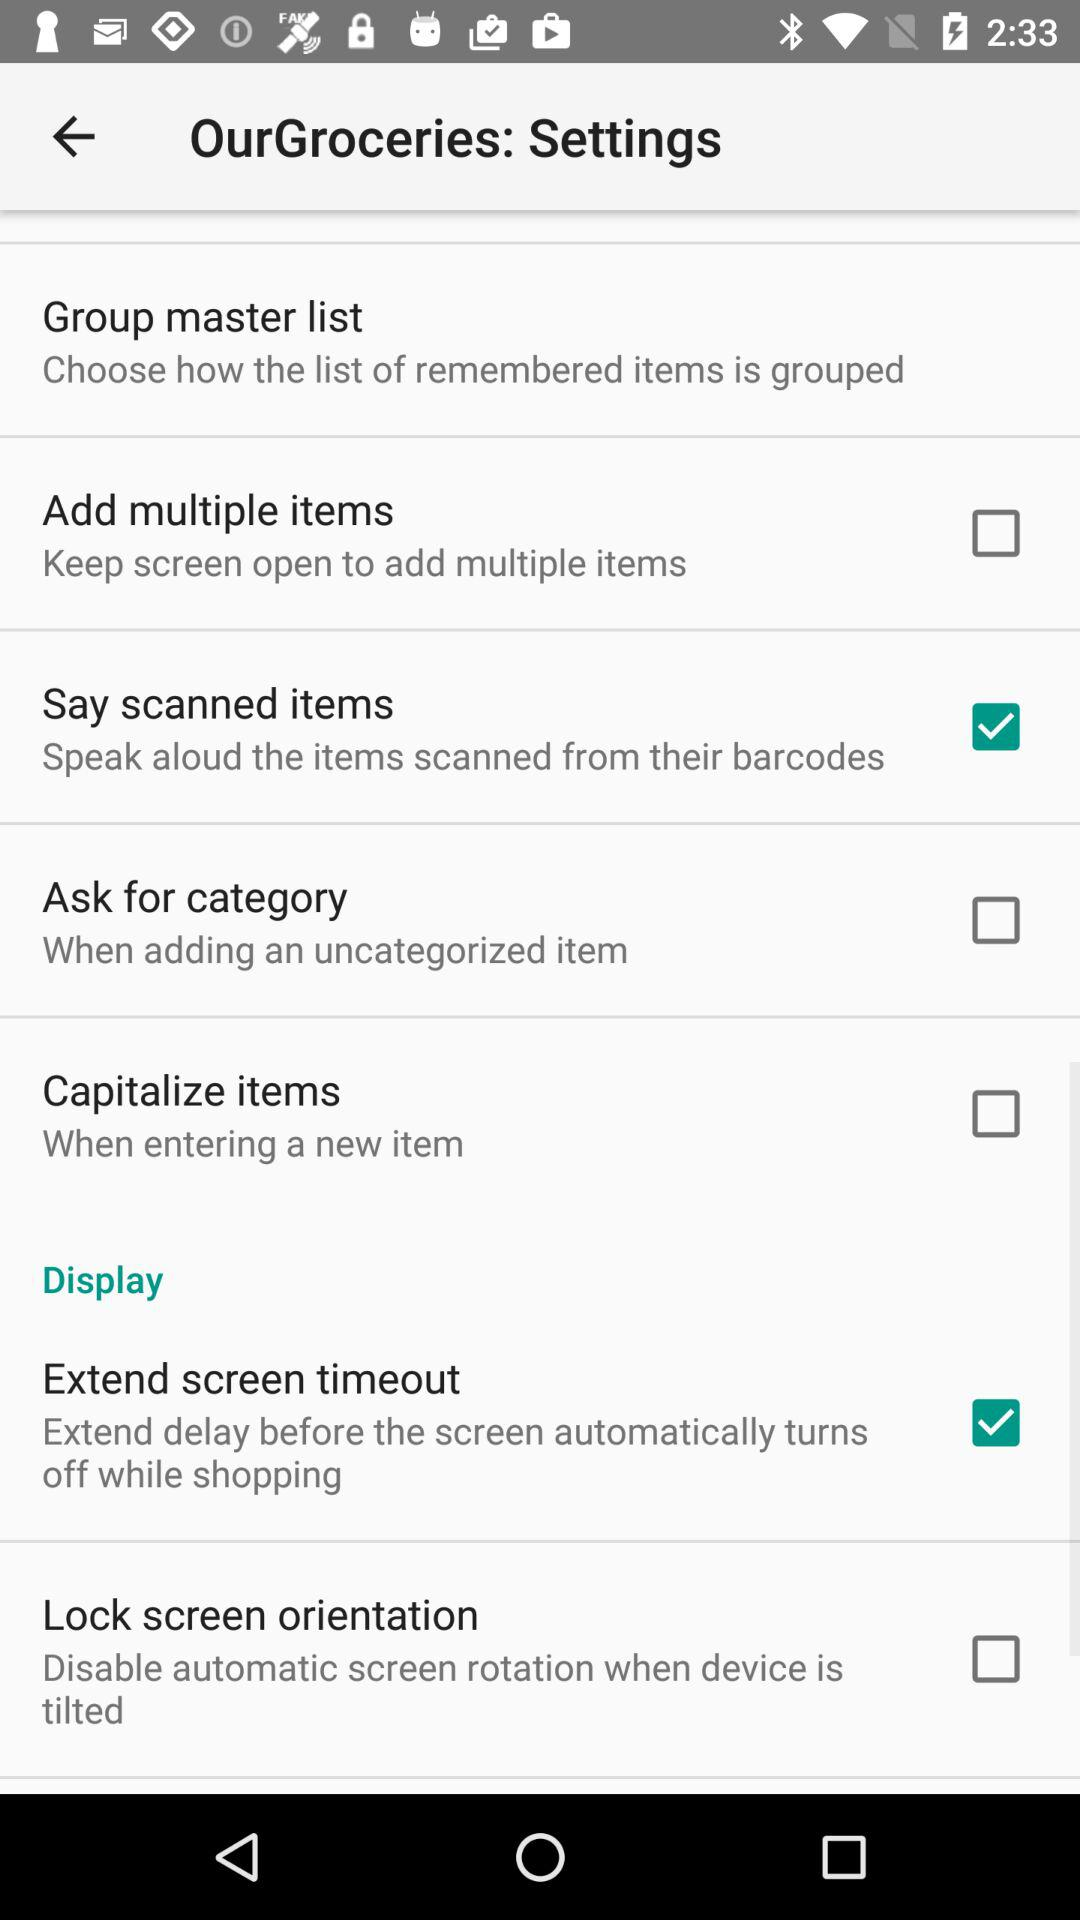Which options are checked? The checked options are "Say scanned items" and "Extend screen timeout". 